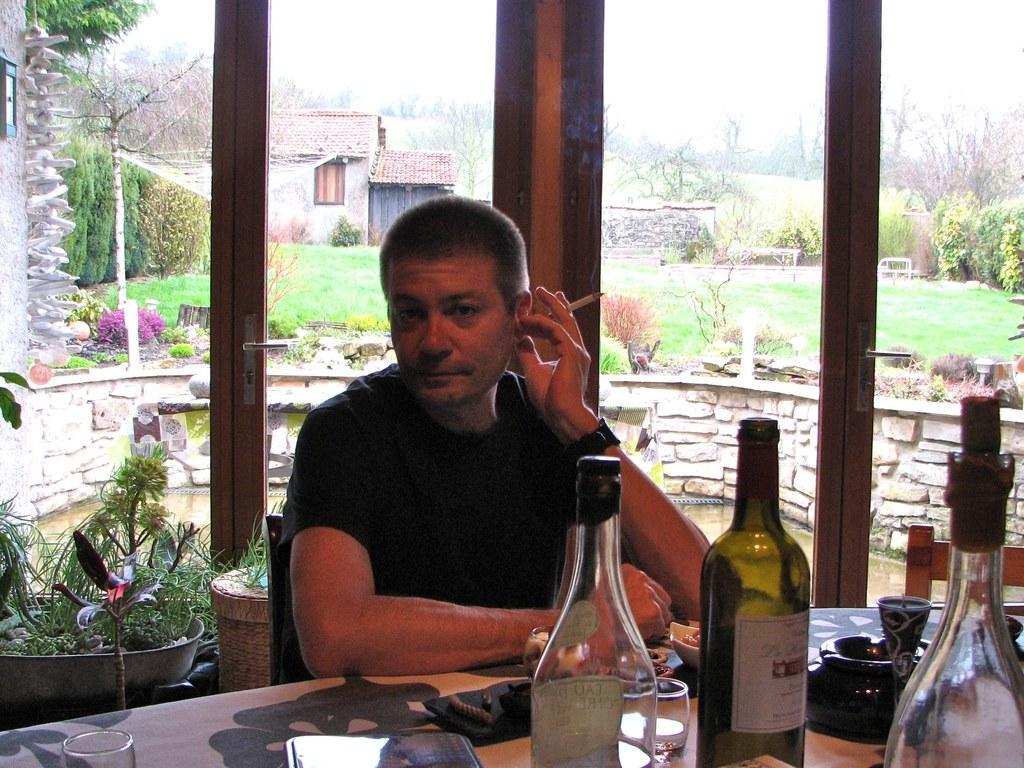How would you summarize this image in a sentence or two? This man wore black t-shirt, holding cigar and sitting on a chair. In-front of this man there is a table, on this table there are bottles, glass, bowl and things. Backside of this person there are plants. From this glass doors we can able to see building with window, plants and trees. 